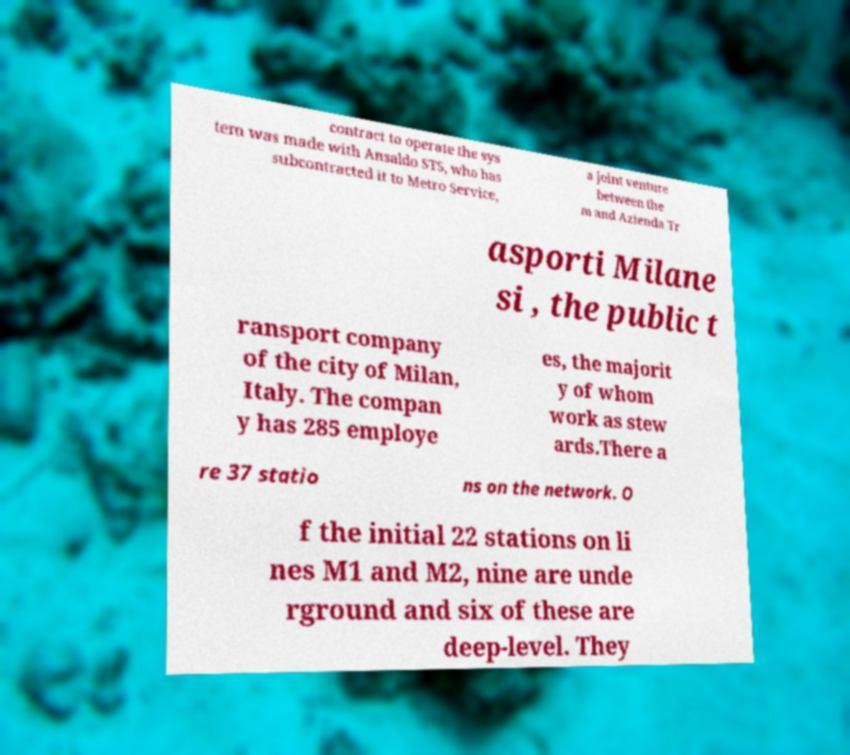Can you accurately transcribe the text from the provided image for me? contract to operate the sys tem was made with Ansaldo STS, who has subcontracted it to Metro Service, a joint venture between the m and Azienda Tr asporti Milane si , the public t ransport company of the city of Milan, Italy. The compan y has 285 employe es, the majorit y of whom work as stew ards.There a re 37 statio ns on the network. O f the initial 22 stations on li nes M1 and M2, nine are unde rground and six of these are deep-level. They 